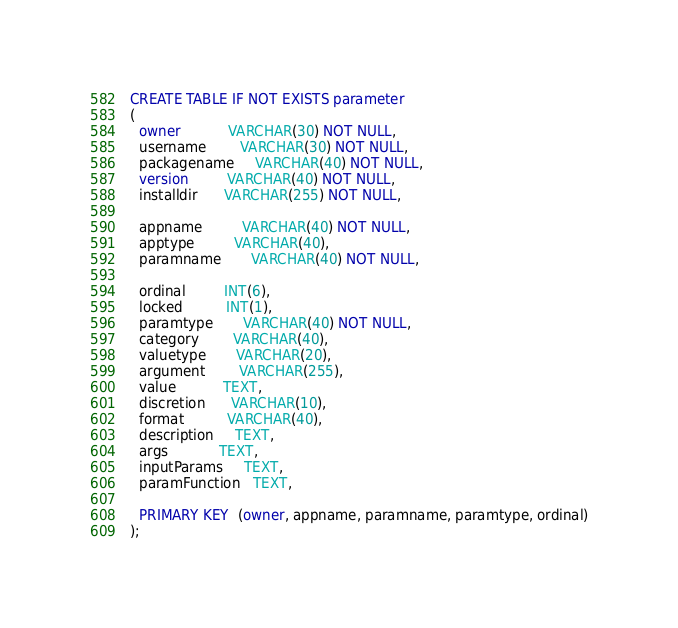<code> <loc_0><loc_0><loc_500><loc_500><_SQL_>CREATE TABLE IF NOT EXISTS parameter
(
  owner           VARCHAR(30) NOT NULL,
  username        VARCHAR(30) NOT NULL,
  packagename     VARCHAR(40) NOT NULL,
  version         VARCHAR(40) NOT NULL,
  installdir      VARCHAR(255) NOT NULL,    

  appname         VARCHAR(40) NOT NULL,
  apptype         VARCHAR(40),    
  paramname       VARCHAR(40) NOT NULL,

  ordinal         INT(6),
  locked          INT(1),
  paramtype       VARCHAR(40) NOT NULL,  
  category        VARCHAR(40),  
  valuetype       VARCHAR(20),  
  argument        VARCHAR(255),  
  value           TEXT,
  discretion      VARCHAR(10),
  format          VARCHAR(40),                      
  description     TEXT, 
  args            TEXT,
  inputParams     TEXT,
  paramFunction   TEXT,

  PRIMARY KEY  (owner, appname, paramname, paramtype, ordinal)
);
</code> 